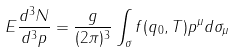Convert formula to latex. <formula><loc_0><loc_0><loc_500><loc_500>E \frac { d ^ { 3 } N } { d ^ { 3 } p } = \frac { g } { ( 2 \pi ) ^ { 3 } } \int _ { \sigma } f ( q _ { 0 } , T ) p ^ { \mu } d \sigma _ { \mu }</formula> 